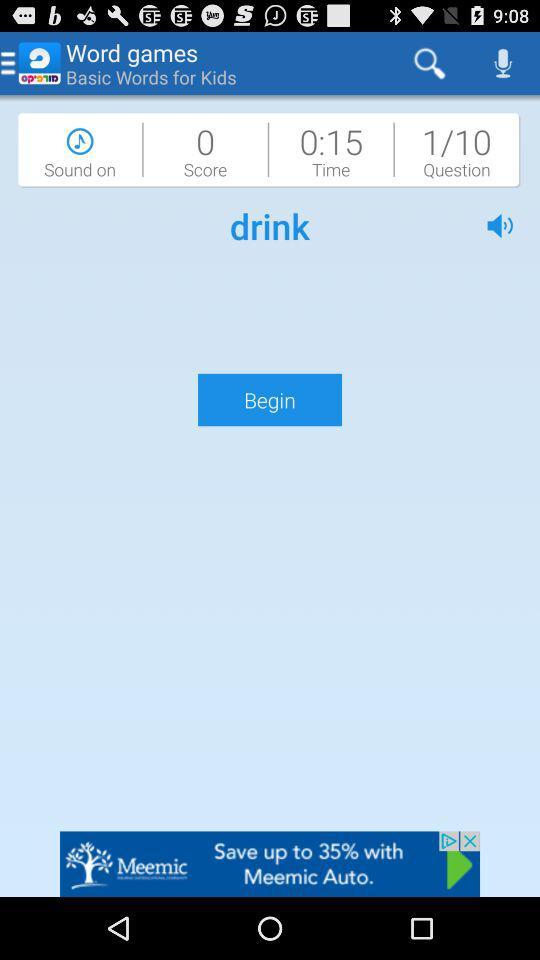How many seconds are left in the game?
Answer the question using a single word or phrase. 15 